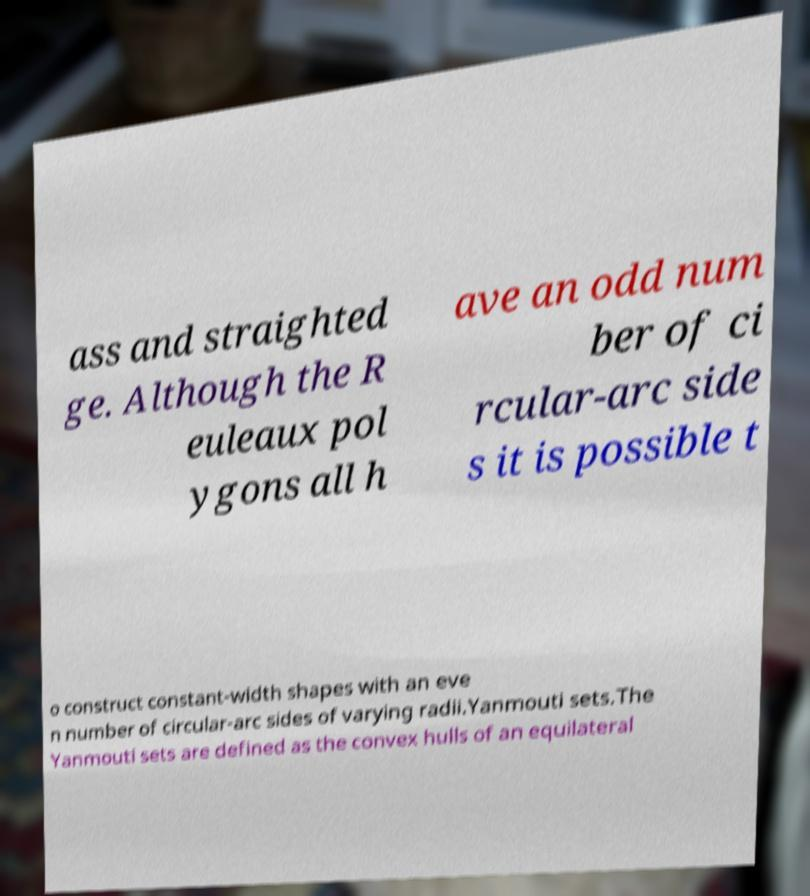For documentation purposes, I need the text within this image transcribed. Could you provide that? ass and straighted ge. Although the R euleaux pol ygons all h ave an odd num ber of ci rcular-arc side s it is possible t o construct constant-width shapes with an eve n number of circular-arc sides of varying radii.Yanmouti sets.The Yanmouti sets are defined as the convex hulls of an equilateral 